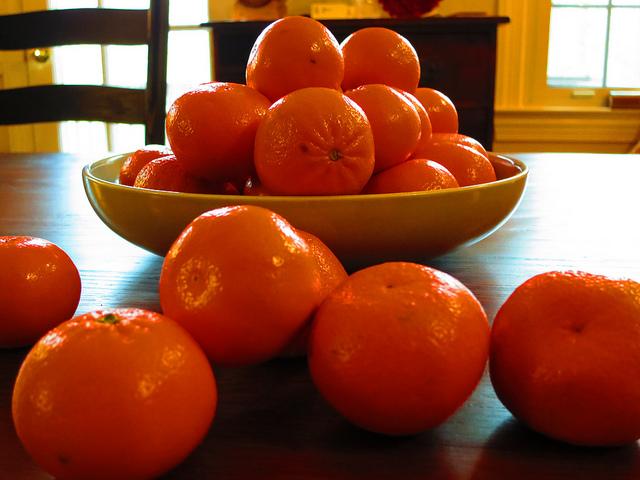How many of the tangerines are not in the bowl?
Answer briefly. 6. What color are the fruit?
Short answer required. Orange. What type of fruit is this?
Concise answer only. Orange. How many chairs do you see?
Short answer required. 1. 